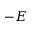<formula> <loc_0><loc_0><loc_500><loc_500>- E</formula> 